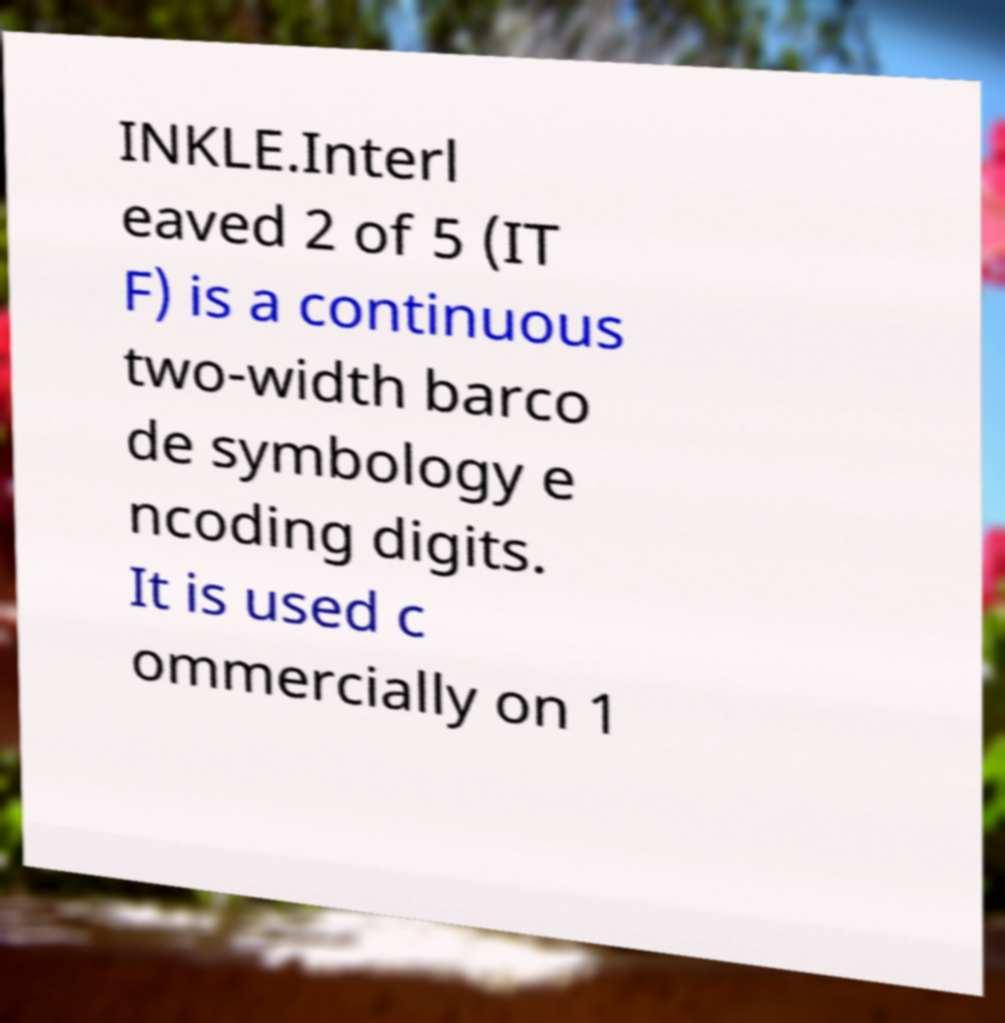Can you read and provide the text displayed in the image?This photo seems to have some interesting text. Can you extract and type it out for me? INKLE.Interl eaved 2 of 5 (IT F) is a continuous two-width barco de symbology e ncoding digits. It is used c ommercially on 1 